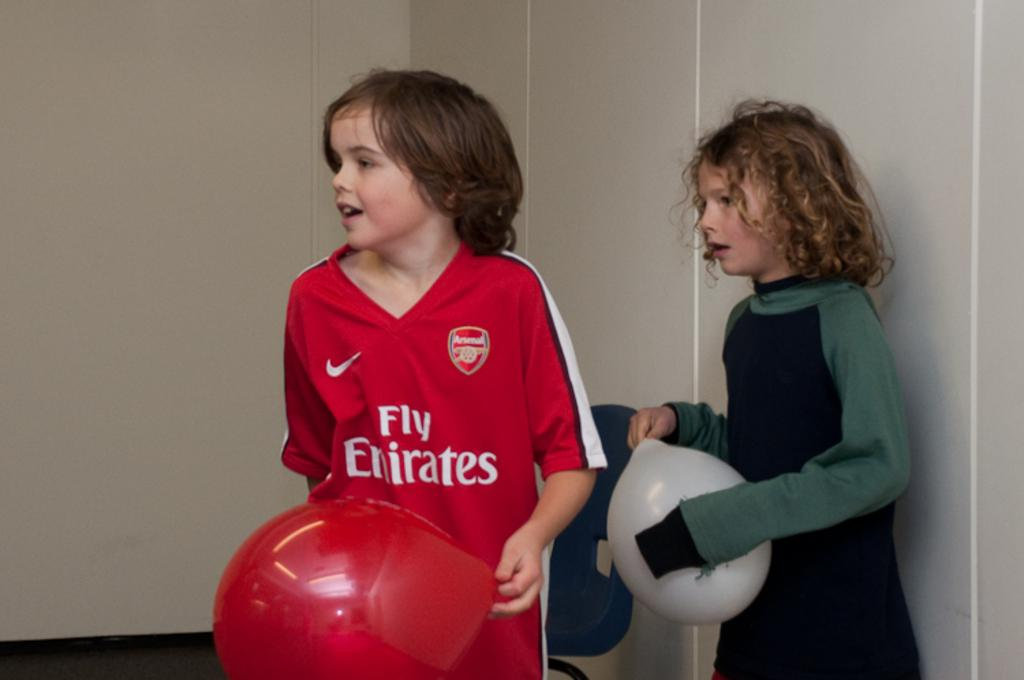Provide a one-sentence caption for the provided image. A boy wears a red jersey that is sponsored by Fly Emirates. 